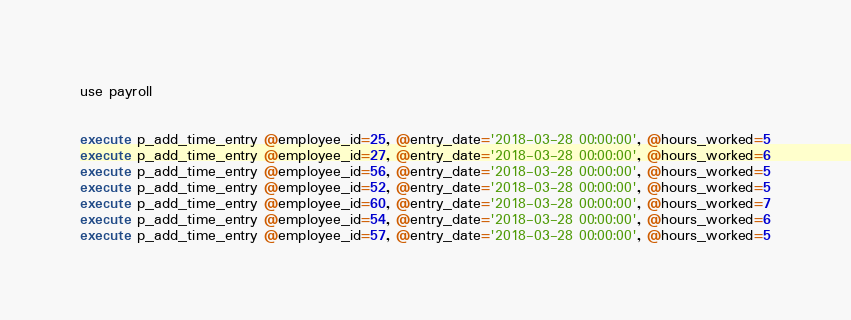Convert code to text. <code><loc_0><loc_0><loc_500><loc_500><_SQL_>use payroll


execute p_add_time_entry @employee_id=25, @entry_date='2018-03-28 00:00:00', @hours_worked=5
execute p_add_time_entry @employee_id=27, @entry_date='2018-03-28 00:00:00', @hours_worked=6
execute p_add_time_entry @employee_id=56, @entry_date='2018-03-28 00:00:00', @hours_worked=5
execute p_add_time_entry @employee_id=52, @entry_date='2018-03-28 00:00:00', @hours_worked=5
execute p_add_time_entry @employee_id=60, @entry_date='2018-03-28 00:00:00', @hours_worked=7
execute p_add_time_entry @employee_id=54, @entry_date='2018-03-28 00:00:00', @hours_worked=6
execute p_add_time_entry @employee_id=57, @entry_date='2018-03-28 00:00:00', @hours_worked=5

</code> 